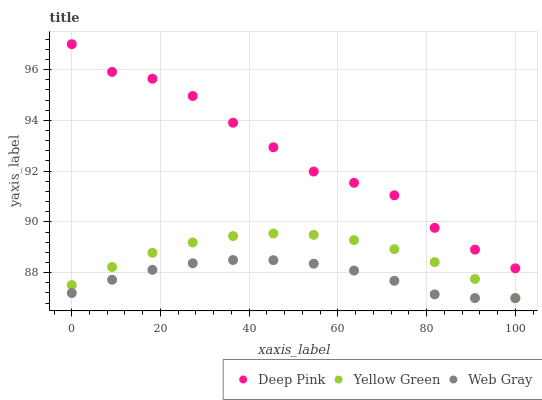Does Web Gray have the minimum area under the curve?
Answer yes or no. Yes. Does Deep Pink have the maximum area under the curve?
Answer yes or no. Yes. Does Yellow Green have the minimum area under the curve?
Answer yes or no. No. Does Yellow Green have the maximum area under the curve?
Answer yes or no. No. Is Yellow Green the smoothest?
Answer yes or no. Yes. Is Deep Pink the roughest?
Answer yes or no. Yes. Is Web Gray the smoothest?
Answer yes or no. No. Is Web Gray the roughest?
Answer yes or no. No. Does Web Gray have the lowest value?
Answer yes or no. Yes. Does Deep Pink have the highest value?
Answer yes or no. Yes. Does Yellow Green have the highest value?
Answer yes or no. No. Is Yellow Green less than Deep Pink?
Answer yes or no. Yes. Is Deep Pink greater than Web Gray?
Answer yes or no. Yes. Does Web Gray intersect Yellow Green?
Answer yes or no. Yes. Is Web Gray less than Yellow Green?
Answer yes or no. No. Is Web Gray greater than Yellow Green?
Answer yes or no. No. Does Yellow Green intersect Deep Pink?
Answer yes or no. No. 